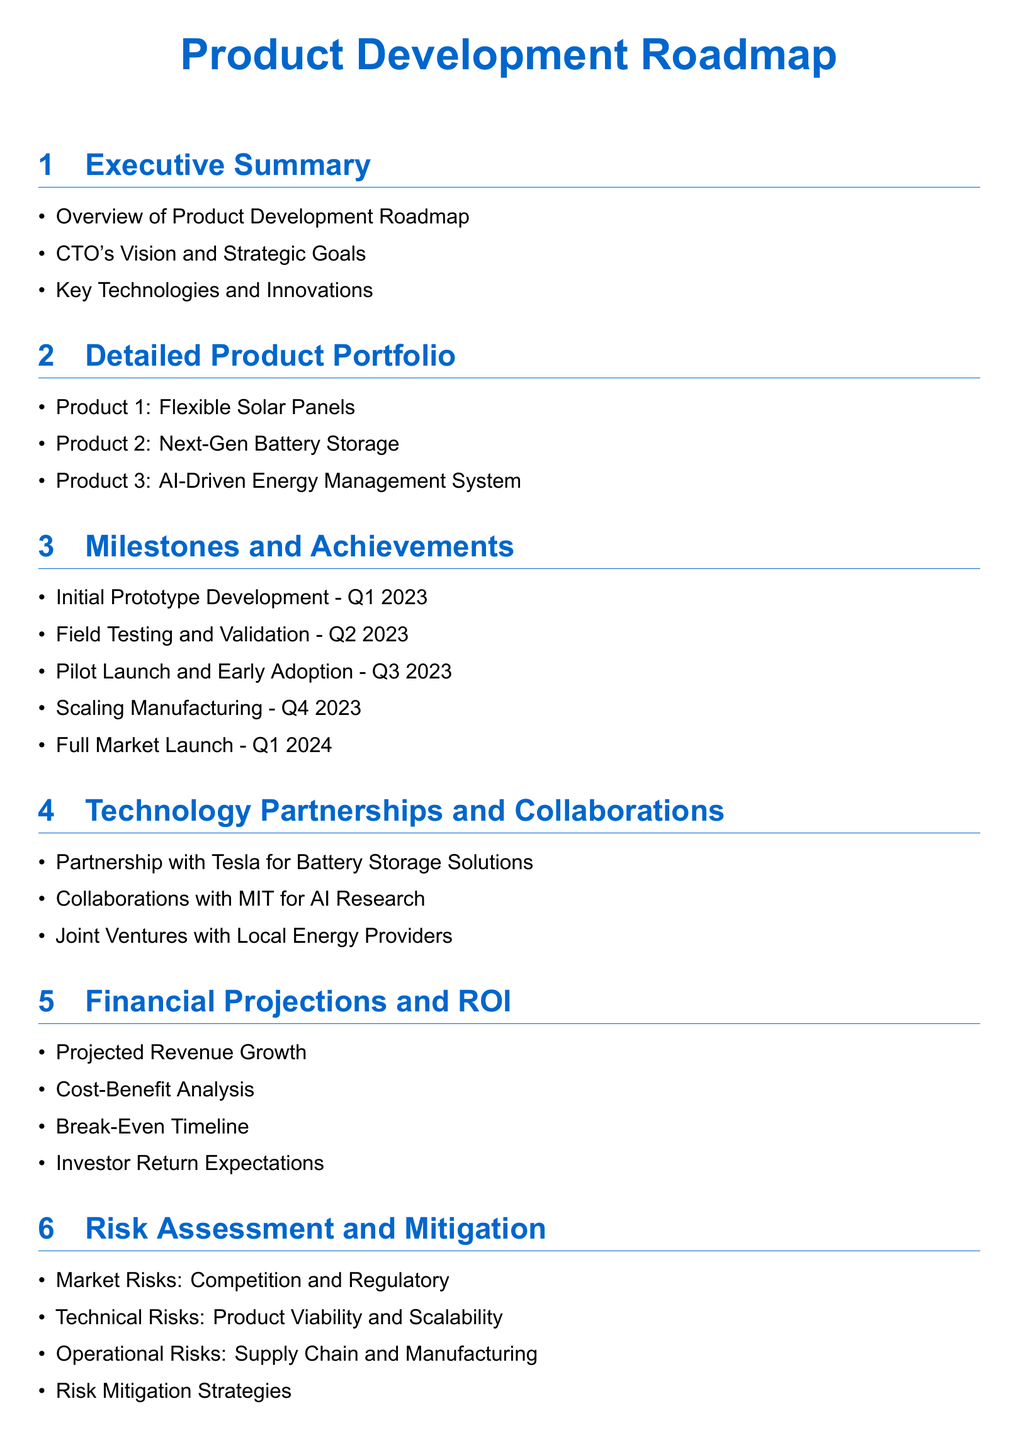What is the first product listed in the portfolio? The first product mentioned in the detailed product portfolio is the Flexible Solar Panels.
Answer: Flexible Solar Panels When was the initial prototype developed? The document states that the initial prototype development milestone was in Q1 2023.
Answer: Q1 2023 What is the main partnership for battery storage solutions? The partnership mentioned for battery storage solutions is with Tesla.
Answer: Tesla How many products are listed in the detailed product portfolio? The document lists three products in the detailed product portfolio.
Answer: Three What is the goal for full market launch? The full market launch is scheduled for Q1 2024.
Answer: Q1 2024 What type of risks are categorized under operational risks? Operational risks include supply chain and manufacturing challenges.
Answer: Supply chain and manufacturing What was the focus of the collaborations with MIT? The collaboration with MIT focuses on AI research.
Answer: AI Research What milestone occurs in Q3 2023? The pilot launch and early adoption milestone occurs in Q3 2023.
Answer: Pilot Launch and Early Adoption 